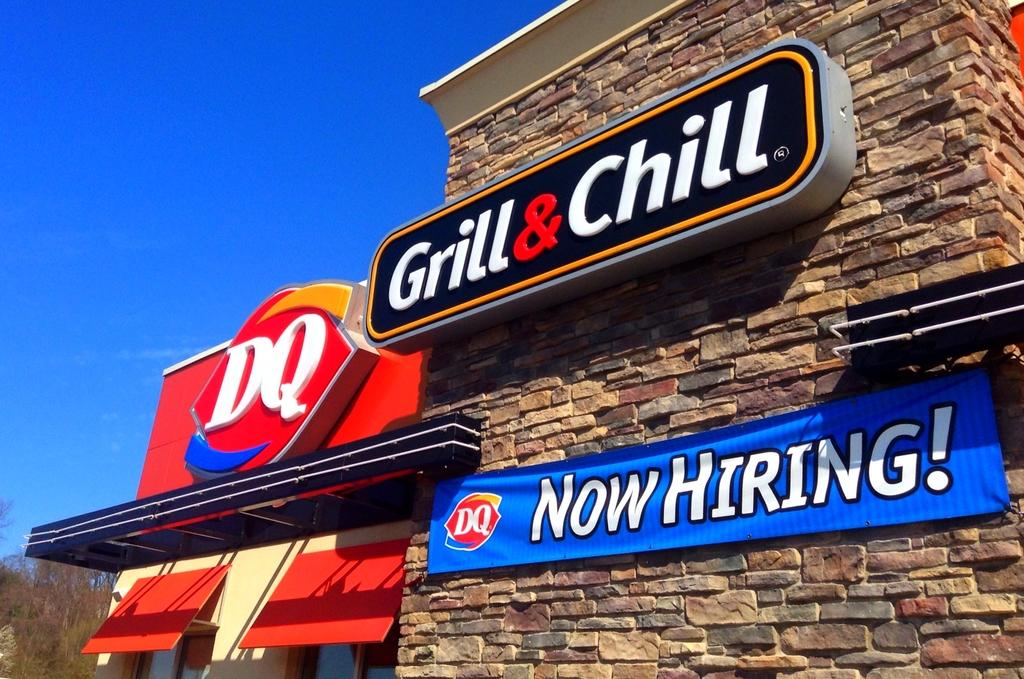What is on the building wall in the image? There is a board with "grill and chill" written on it in the image. What part of a house can be seen in the image? There is a part of a house with two windows in the image. What type of vegetation is visible in the image? There are trees visible in the image. What is visible in the background of the image? The sky is visible in the image. Can you tell me how many cows are visible in the image? There are no cows present in the image. What type of connection is visible between the house and the building wall in the image? There is no connection between the house and the building wall in the image; they are separate structures. 